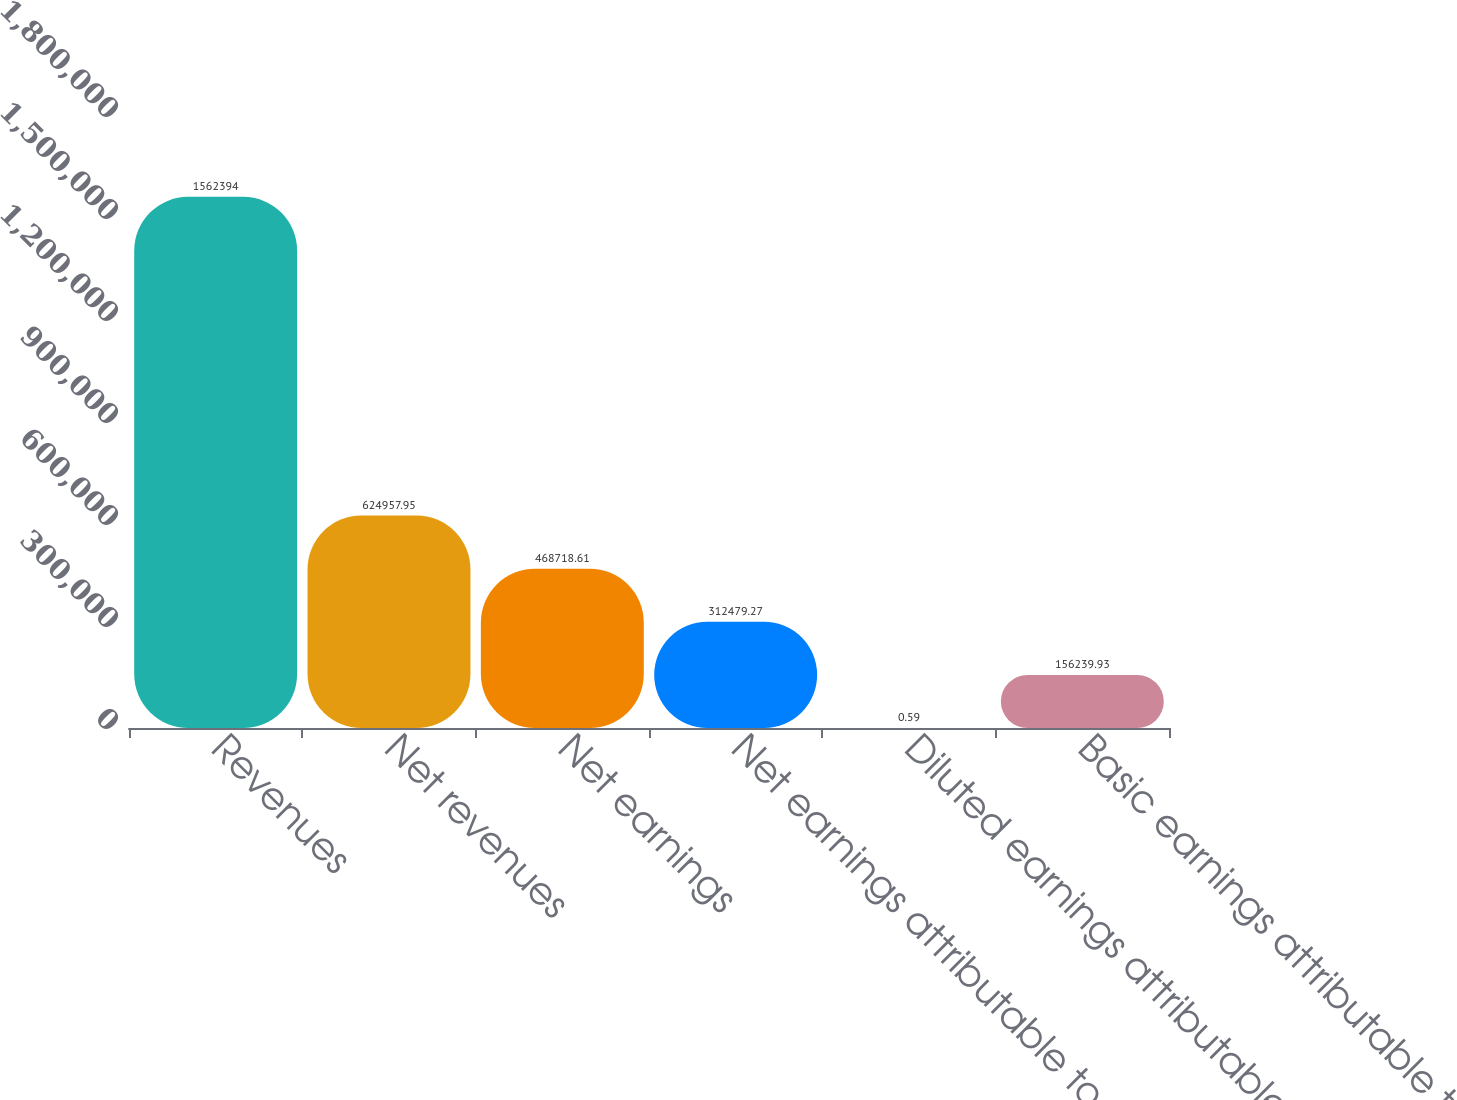<chart> <loc_0><loc_0><loc_500><loc_500><bar_chart><fcel>Revenues<fcel>Net revenues<fcel>Net earnings<fcel>Net earnings attributable to<fcel>Diluted earnings attributable<fcel>Basic earnings attributable to<nl><fcel>1.56239e+06<fcel>624958<fcel>468719<fcel>312479<fcel>0.59<fcel>156240<nl></chart> 